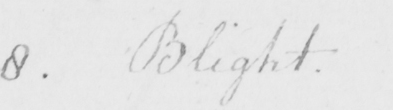Transcribe the text shown in this historical manuscript line. 8 . Blight 